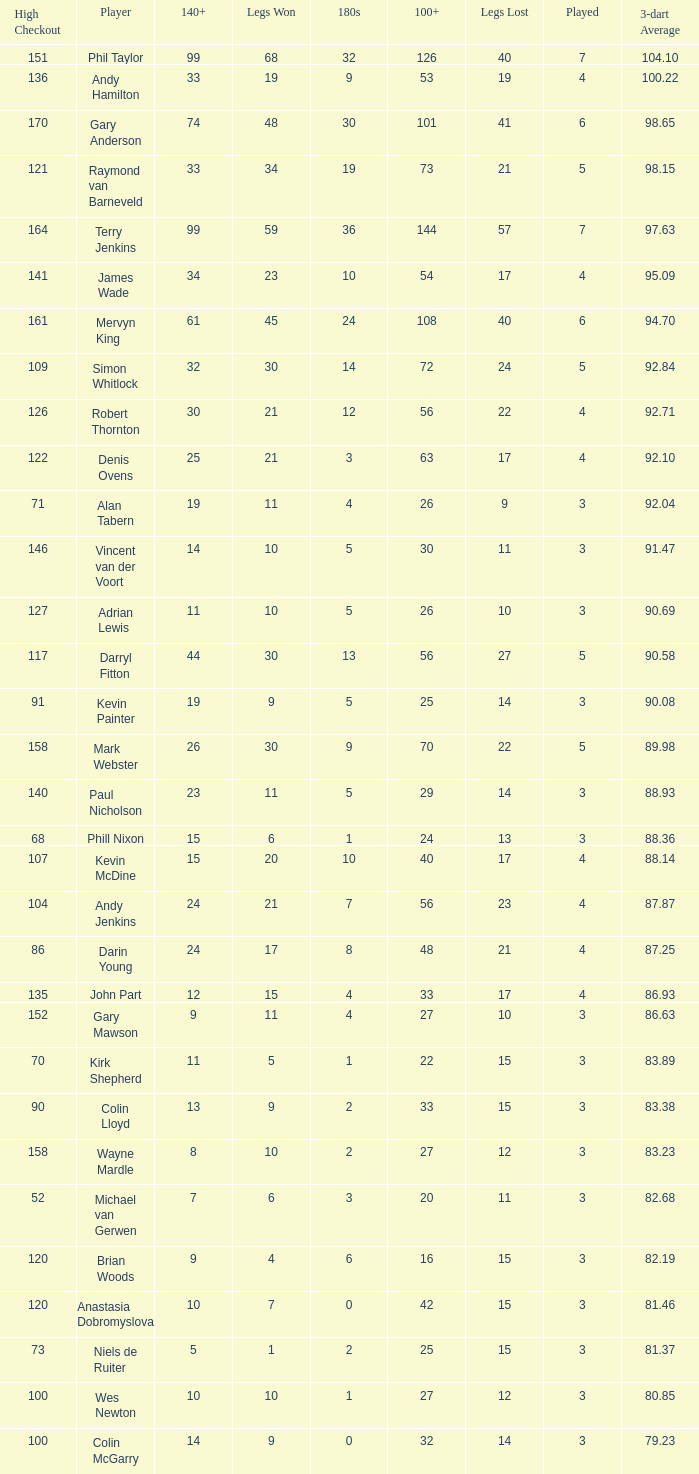What is the number of high checkout when legs Lost is 17, 140+ is 15, and played is larger than 4? None. 